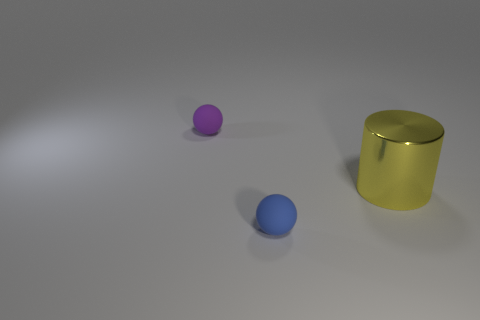Is the shape of the blue object the same as the purple object?
Your answer should be very brief. Yes. Is there anything else that has the same shape as the big thing?
Ensure brevity in your answer.  No. Is the number of purple rubber objects in front of the yellow cylinder less than the number of large yellow metallic objects that are behind the tiny blue object?
Ensure brevity in your answer.  Yes. What is the shape of the thing that is in front of the yellow thing?
Provide a short and direct response. Sphere. What number of other things are the same material as the blue thing?
Keep it short and to the point. 1. There is a big yellow shiny object; is it the same shape as the blue rubber object in front of the yellow metallic cylinder?
Make the answer very short. No. There is a tiny purple object that is the same material as the tiny blue thing; what is its shape?
Provide a short and direct response. Sphere. Is the number of tiny balls that are behind the cylinder greater than the number of blue things on the right side of the tiny blue sphere?
Your answer should be very brief. Yes. How many things are either gray cubes or matte objects?
Provide a short and direct response. 2. The other thing that is the same size as the purple matte object is what shape?
Make the answer very short. Sphere. 